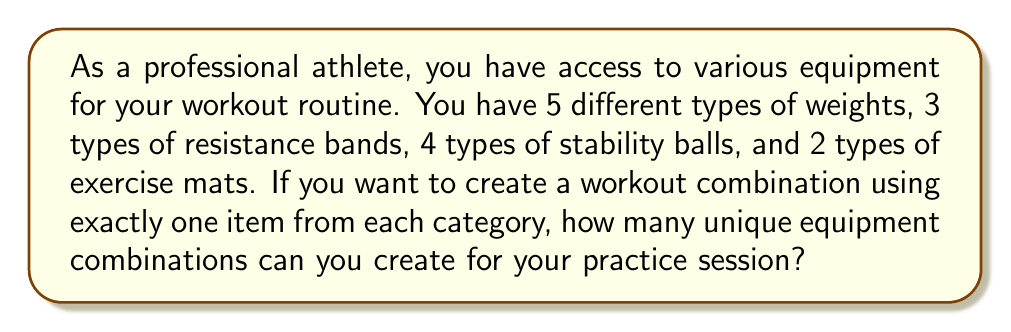Help me with this question. Let's approach this step-by-step using the multiplication principle of counting:

1) We need to choose one item from each category:
   - 5 types of weights
   - 3 types of resistance bands
   - 4 types of stability balls
   - 2 types of exercise mats

2) For each category, we have independent choices. This means we can multiply the number of options for each category:

   $$ \text{Total combinations} = \text{Weights} \times \text{Resistance bands} \times \text{Stability balls} \times \text{Exercise mats} $$

3) Substituting the values:

   $$ \text{Total combinations} = 5 \times 3 \times 4 \times 2 $$

4) Calculating:

   $$ \text{Total combinations} = 120 $$

Therefore, you can create 120 unique equipment combinations for your workout, allowing you to vary your practice routine and target different aspects of your performance.
Answer: 120 